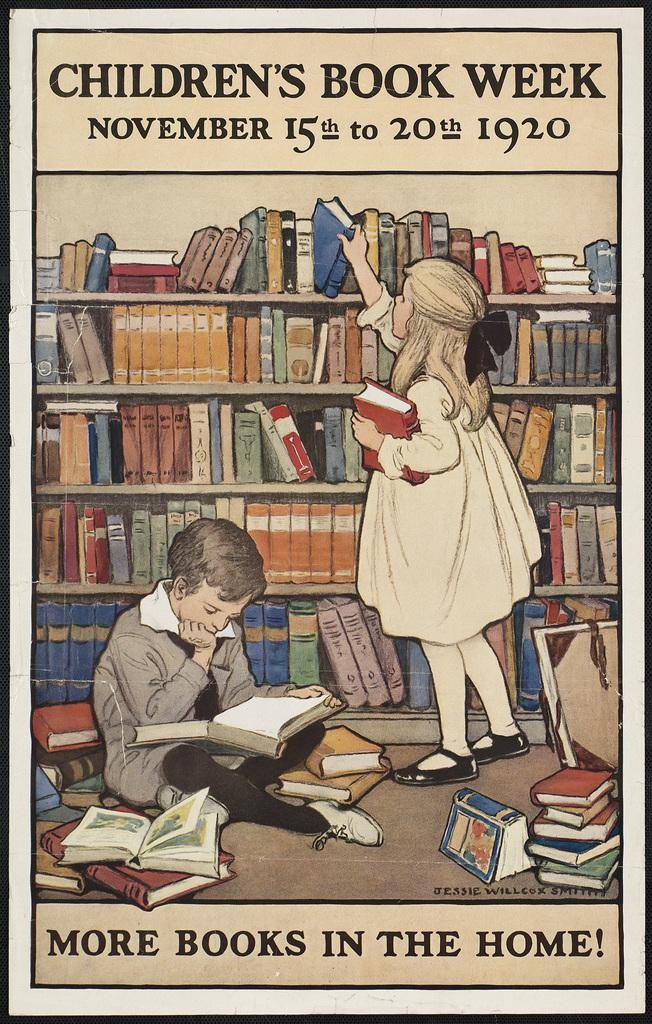<image>
Present a compact description of the photo's key features. A poster for Children's Book Week showing two children surrounded by books. 